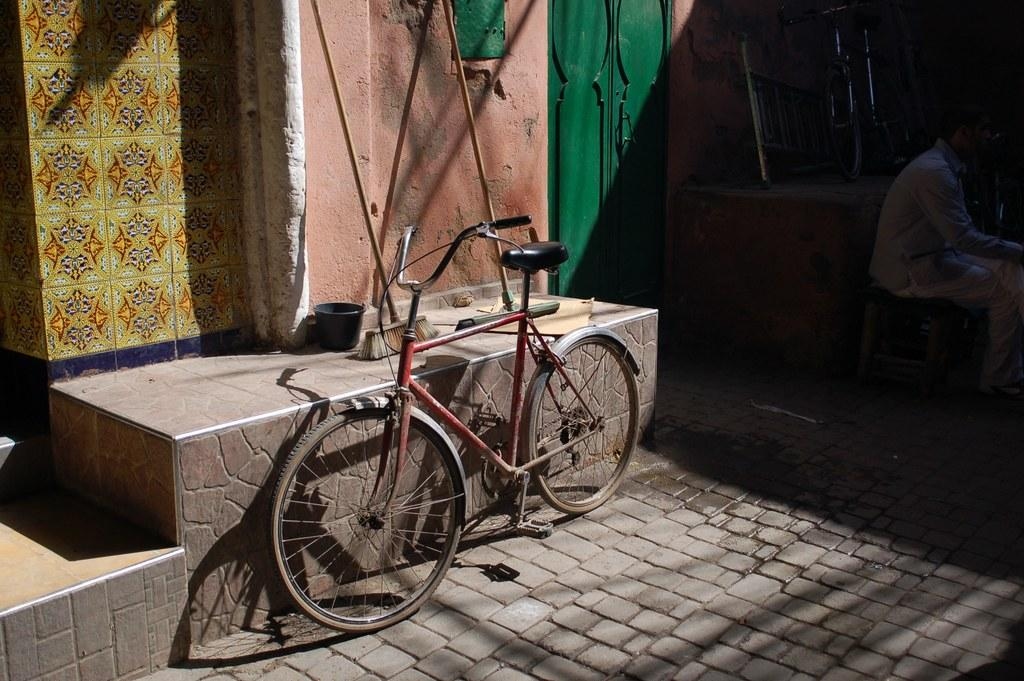What is the main object in the center of the image? There is a cycle in the center of the image. Where is the cycle located? The cycle is on the floor. What can be seen in the background of the image? There is a person, a door, and a building in the background of the image. How do the giants interact with the cycle in the image? There are no giants present in the image, so they cannot interact with the cycle. 